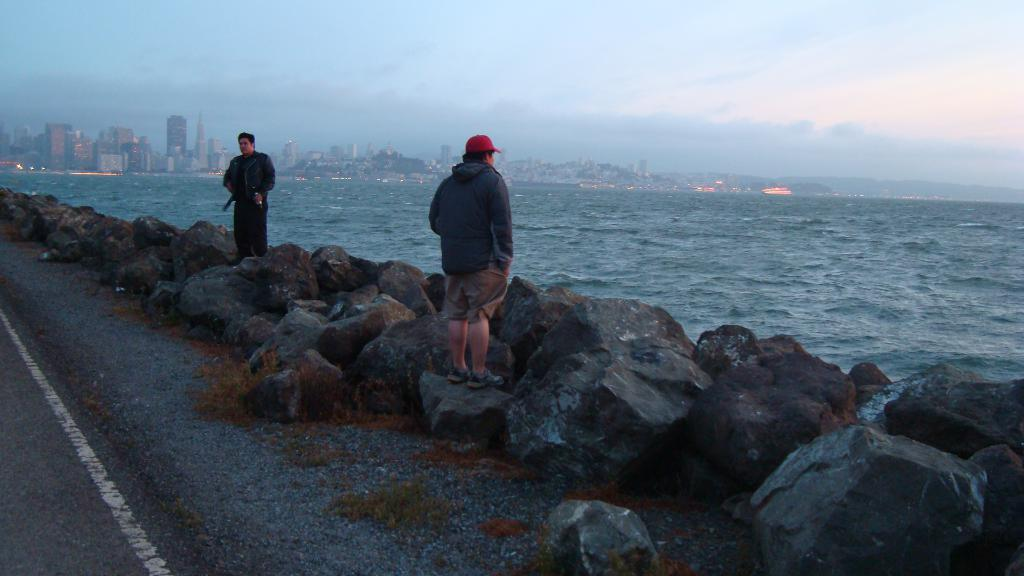How many people are in the image? There are two men standing in the image. What type of natural feature is present in the image? There are rocks in the image. What can be seen in the background of the image? The view of a city with buildings is visible in the image. What type of man-made structure is present in the image? There is a road in the image. What type of ornament is hanging from the rocks in the image? There is no ornament hanging from the rocks in the image; the rocks are a natural feature. 